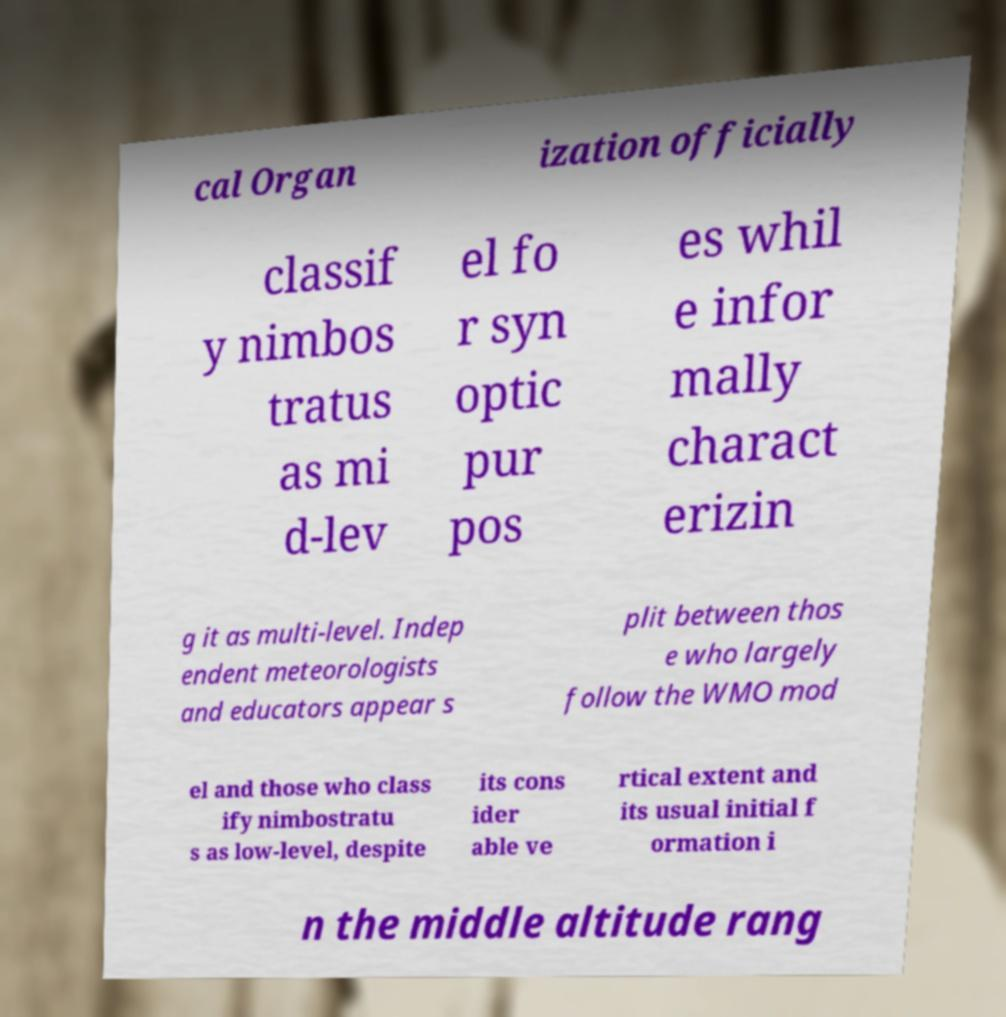Please identify and transcribe the text found in this image. cal Organ ization officially classif y nimbos tratus as mi d-lev el fo r syn optic pur pos es whil e infor mally charact erizin g it as multi-level. Indep endent meteorologists and educators appear s plit between thos e who largely follow the WMO mod el and those who class ify nimbostratu s as low-level, despite its cons ider able ve rtical extent and its usual initial f ormation i n the middle altitude rang 